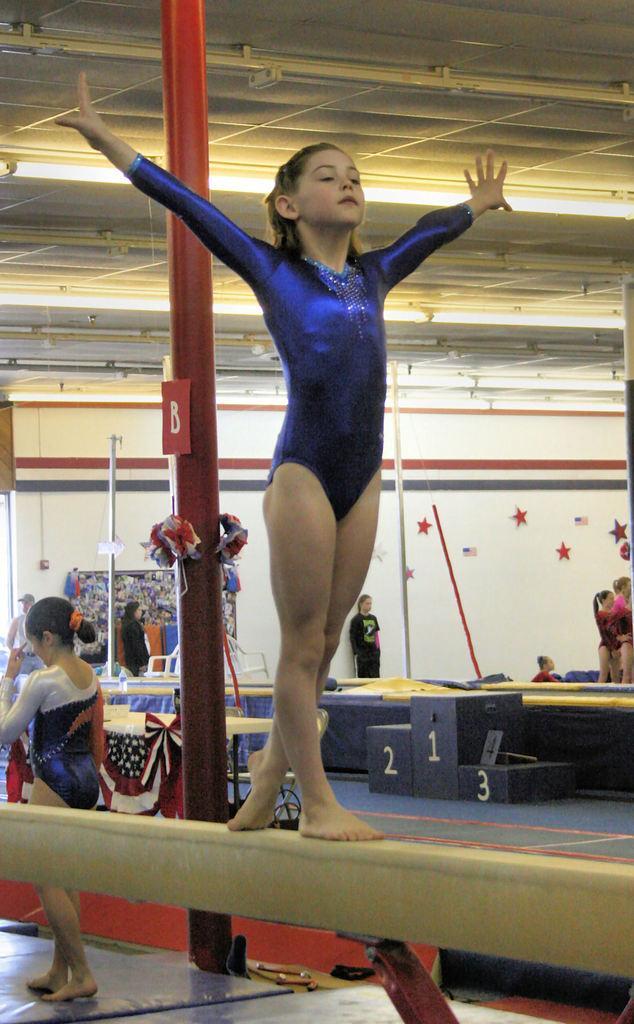Describe this image in one or two sentences. In this image I can see a woman is standing. In the background I can see poles, people and some other objects on the floor. I can also see a wall which has some objects attached to it and lights on the ceiling. 